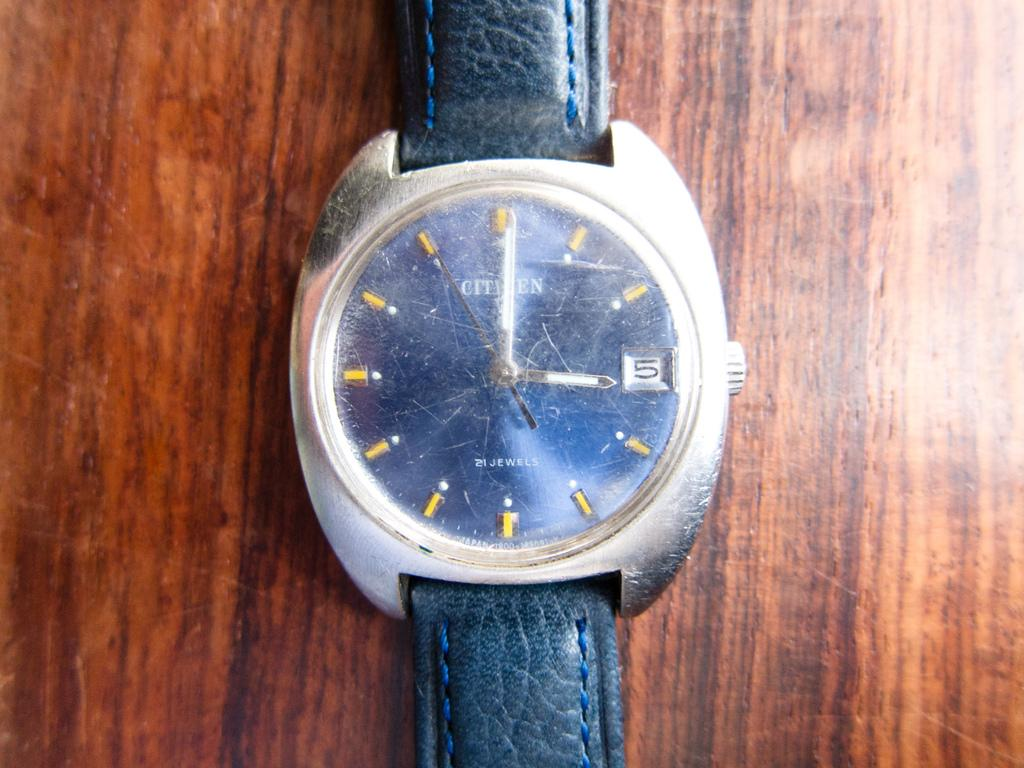<image>
Render a clear and concise summary of the photo. a scratched face of a Citizen watch on a wood table 